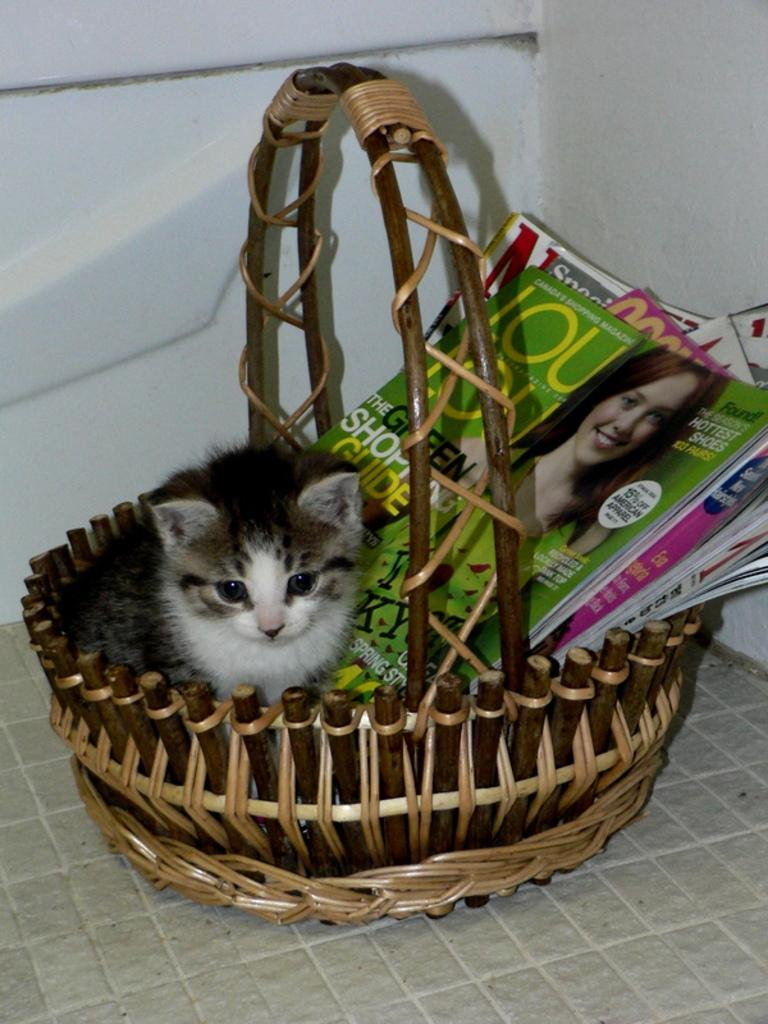What object is in the image that can hold items? There is a basket in the image that can hold items. What is inside the basket in the image? A cat is present in the basket, along with some books. Where is the basket located in the image? The basket is placed on the floor. What can be seen in the background of the image? There are walls visible in the background of the image. How does the cat control the yoke in the image? There is no yoke present in the image, and therefore the cat cannot control it. 